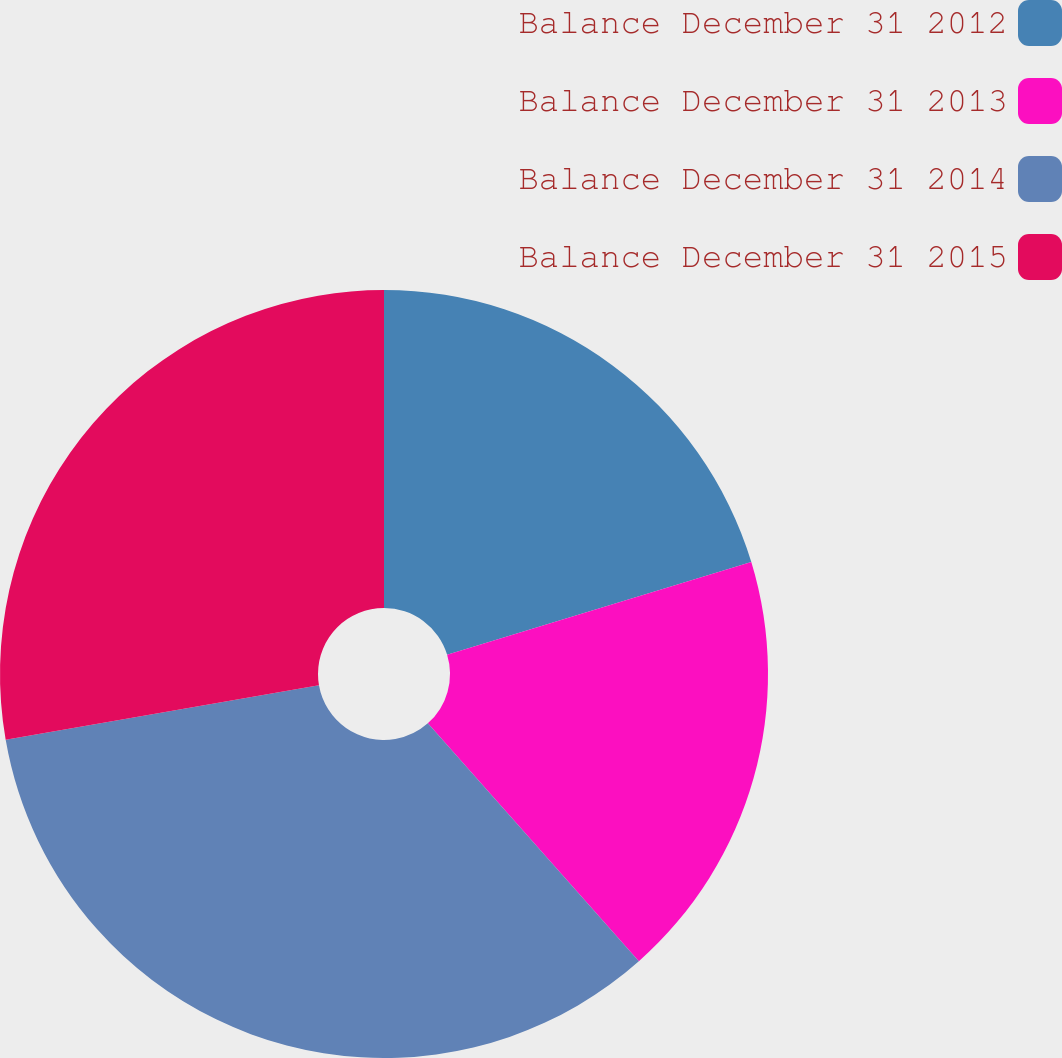Convert chart. <chart><loc_0><loc_0><loc_500><loc_500><pie_chart><fcel>Balance December 31 2012<fcel>Balance December 31 2013<fcel>Balance December 31 2014<fcel>Balance December 31 2015<nl><fcel>20.29%<fcel>18.16%<fcel>33.81%<fcel>27.74%<nl></chart> 